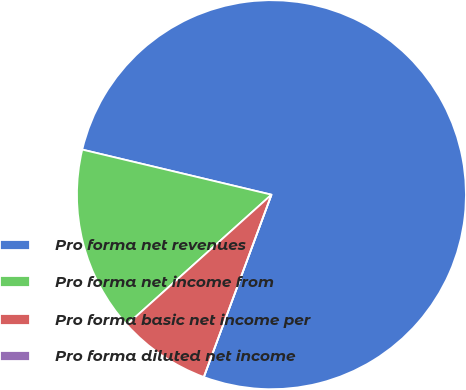<chart> <loc_0><loc_0><loc_500><loc_500><pie_chart><fcel>Pro forma net revenues<fcel>Pro forma net income from<fcel>Pro forma basic net income per<fcel>Pro forma diluted net income<nl><fcel>76.92%<fcel>15.38%<fcel>7.69%<fcel>0.0%<nl></chart> 